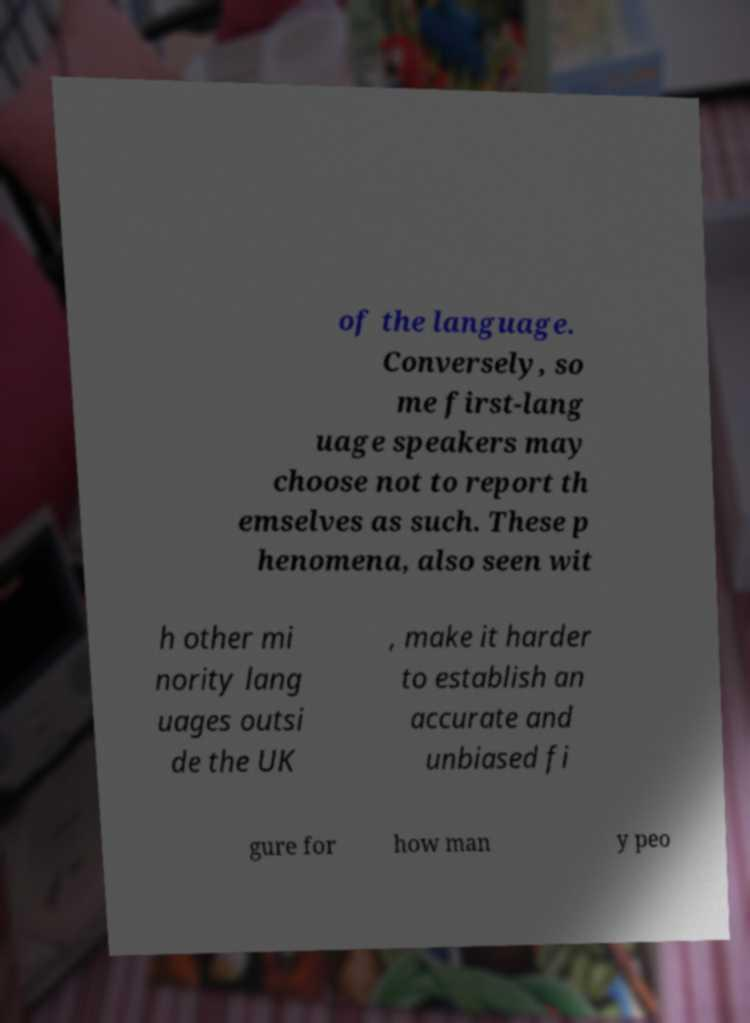What messages or text are displayed in this image? I need them in a readable, typed format. of the language. Conversely, so me first-lang uage speakers may choose not to report th emselves as such. These p henomena, also seen wit h other mi nority lang uages outsi de the UK , make it harder to establish an accurate and unbiased fi gure for how man y peo 